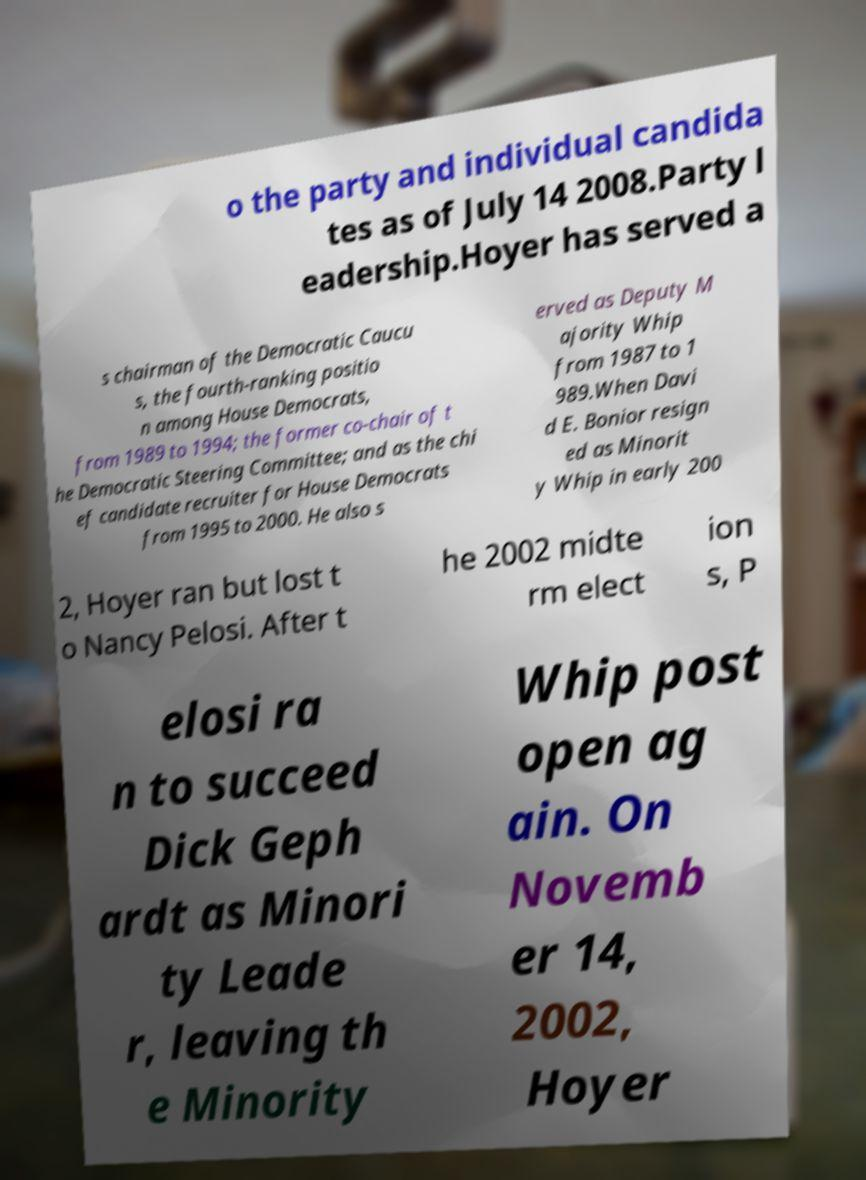Please read and relay the text visible in this image. What does it say? o the party and individual candida tes as of July 14 2008.Party l eadership.Hoyer has served a s chairman of the Democratic Caucu s, the fourth-ranking positio n among House Democrats, from 1989 to 1994; the former co-chair of t he Democratic Steering Committee; and as the chi ef candidate recruiter for House Democrats from 1995 to 2000. He also s erved as Deputy M ajority Whip from 1987 to 1 989.When Davi d E. Bonior resign ed as Minorit y Whip in early 200 2, Hoyer ran but lost t o Nancy Pelosi. After t he 2002 midte rm elect ion s, P elosi ra n to succeed Dick Geph ardt as Minori ty Leade r, leaving th e Minority Whip post open ag ain. On Novemb er 14, 2002, Hoyer 